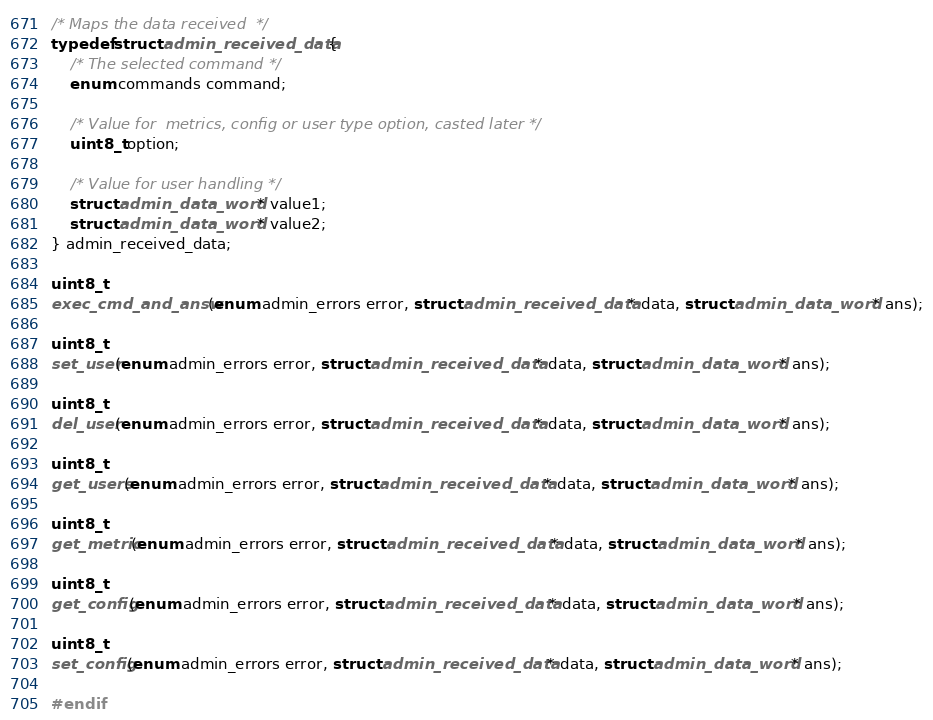Convert code to text. <code><loc_0><loc_0><loc_500><loc_500><_C_>/* Maps the data received  */
typedef struct admin_received_data {
    /* The selected command */
    enum commands command;
    
    /* Value for  metrics, config or user type option, casted later */
    uint8_t option;

    /* Value for user handling */
    struct admin_data_word * value1;
    struct admin_data_word * value2;
} admin_received_data;

uint8_t
exec_cmd_and_answ(enum admin_errors error, struct admin_received_data * data, struct admin_data_word * ans);

uint8_t
set_user(enum admin_errors error, struct admin_received_data * data, struct admin_data_word * ans);

uint8_t
del_user(enum admin_errors error, struct admin_received_data * data, struct admin_data_word * ans);

uint8_t
get_users(enum admin_errors error, struct admin_received_data * data, struct admin_data_word * ans);

uint8_t
get_metric(enum admin_errors error, struct admin_received_data * data, struct admin_data_word * ans);

uint8_t
get_config(enum admin_errors error, struct admin_received_data * data, struct admin_data_word * ans);

uint8_t
set_config(enum admin_errors error, struct admin_received_data * data, struct admin_data_word * ans);

#endif</code> 